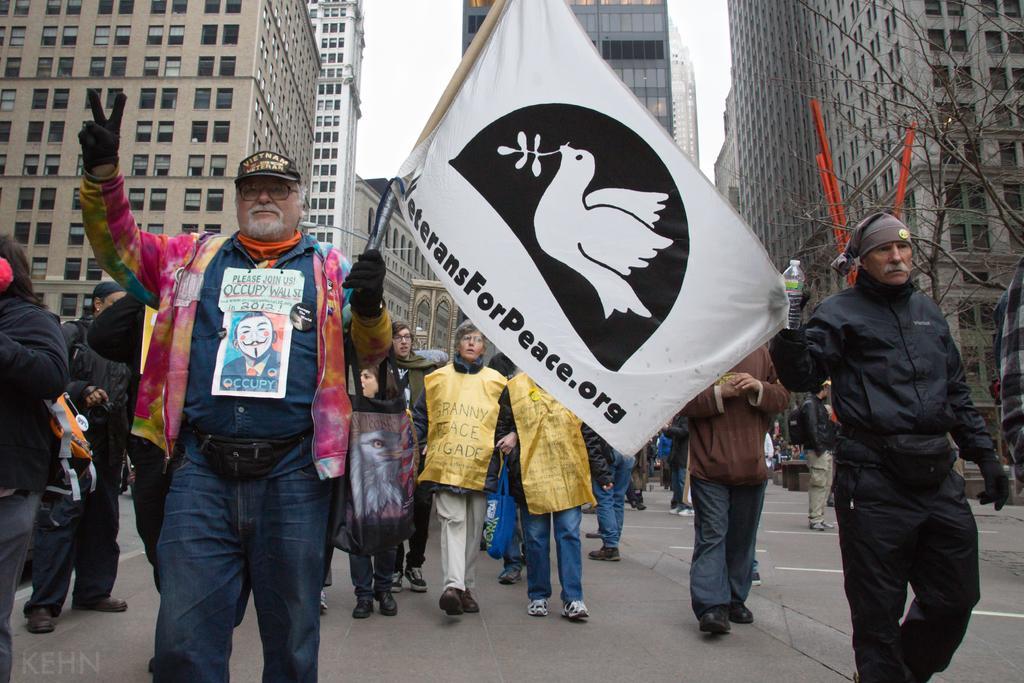In one or two sentences, can you explain what this image depicts? This image is taken outdoors. At the top of the image there is the sky. At the bottom of the image there is a road. In the background there are many buildings. In the middle of the image many people are walking on the road. Two men are holding a flag with a text on it. On the right side of the image there is a tree. 